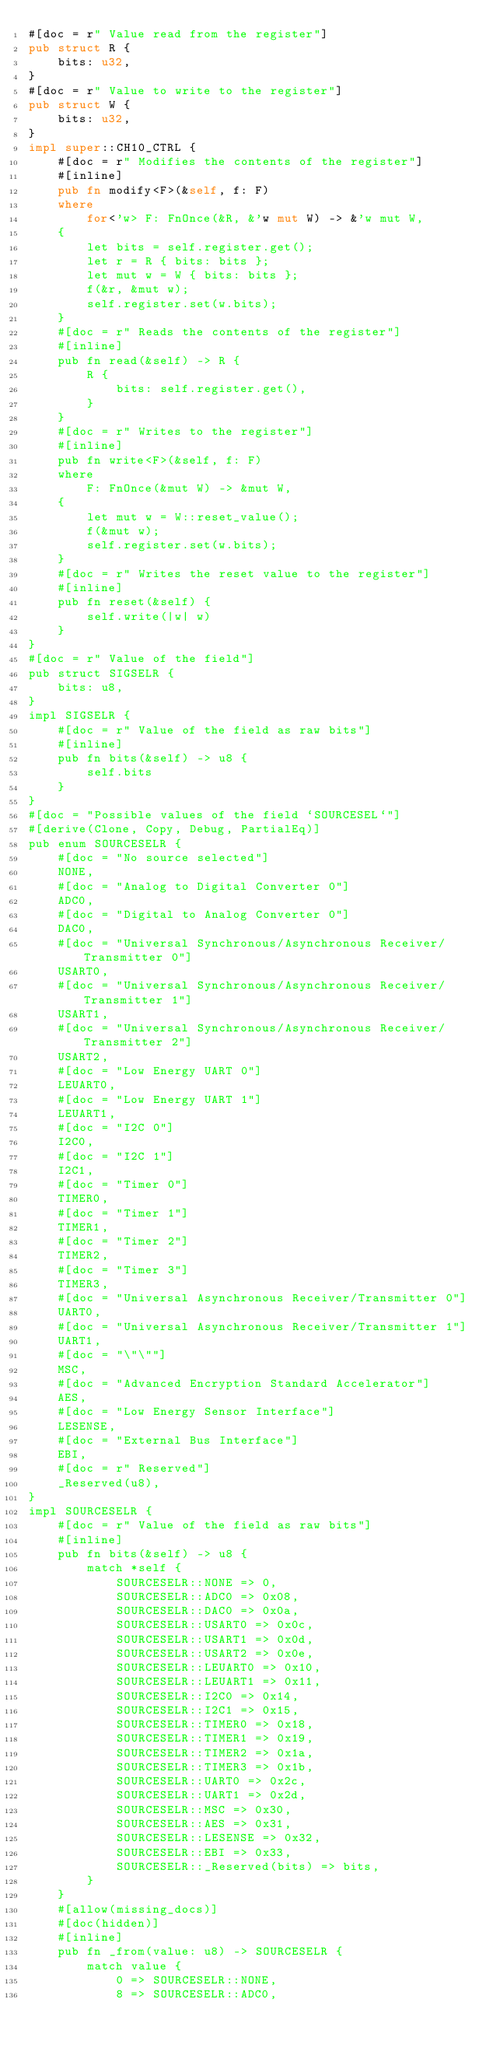Convert code to text. <code><loc_0><loc_0><loc_500><loc_500><_Rust_>#[doc = r" Value read from the register"]
pub struct R {
    bits: u32,
}
#[doc = r" Value to write to the register"]
pub struct W {
    bits: u32,
}
impl super::CH10_CTRL {
    #[doc = r" Modifies the contents of the register"]
    #[inline]
    pub fn modify<F>(&self, f: F)
    where
        for<'w> F: FnOnce(&R, &'w mut W) -> &'w mut W,
    {
        let bits = self.register.get();
        let r = R { bits: bits };
        let mut w = W { bits: bits };
        f(&r, &mut w);
        self.register.set(w.bits);
    }
    #[doc = r" Reads the contents of the register"]
    #[inline]
    pub fn read(&self) -> R {
        R {
            bits: self.register.get(),
        }
    }
    #[doc = r" Writes to the register"]
    #[inline]
    pub fn write<F>(&self, f: F)
    where
        F: FnOnce(&mut W) -> &mut W,
    {
        let mut w = W::reset_value();
        f(&mut w);
        self.register.set(w.bits);
    }
    #[doc = r" Writes the reset value to the register"]
    #[inline]
    pub fn reset(&self) {
        self.write(|w| w)
    }
}
#[doc = r" Value of the field"]
pub struct SIGSELR {
    bits: u8,
}
impl SIGSELR {
    #[doc = r" Value of the field as raw bits"]
    #[inline]
    pub fn bits(&self) -> u8 {
        self.bits
    }
}
#[doc = "Possible values of the field `SOURCESEL`"]
#[derive(Clone, Copy, Debug, PartialEq)]
pub enum SOURCESELR {
    #[doc = "No source selected"]
    NONE,
    #[doc = "Analog to Digital Converter 0"]
    ADC0,
    #[doc = "Digital to Analog Converter 0"]
    DAC0,
    #[doc = "Universal Synchronous/Asynchronous Receiver/Transmitter 0"]
    USART0,
    #[doc = "Universal Synchronous/Asynchronous Receiver/Transmitter 1"]
    USART1,
    #[doc = "Universal Synchronous/Asynchronous Receiver/Transmitter 2"]
    USART2,
    #[doc = "Low Energy UART 0"]
    LEUART0,
    #[doc = "Low Energy UART 1"]
    LEUART1,
    #[doc = "I2C 0"]
    I2C0,
    #[doc = "I2C 1"]
    I2C1,
    #[doc = "Timer 0"]
    TIMER0,
    #[doc = "Timer 1"]
    TIMER1,
    #[doc = "Timer 2"]
    TIMER2,
    #[doc = "Timer 3"]
    TIMER3,
    #[doc = "Universal Asynchronous Receiver/Transmitter 0"]
    UART0,
    #[doc = "Universal Asynchronous Receiver/Transmitter 1"]
    UART1,
    #[doc = "\"\""]
    MSC,
    #[doc = "Advanced Encryption Standard Accelerator"]
    AES,
    #[doc = "Low Energy Sensor Interface"]
    LESENSE,
    #[doc = "External Bus Interface"]
    EBI,
    #[doc = r" Reserved"]
    _Reserved(u8),
}
impl SOURCESELR {
    #[doc = r" Value of the field as raw bits"]
    #[inline]
    pub fn bits(&self) -> u8 {
        match *self {
            SOURCESELR::NONE => 0,
            SOURCESELR::ADC0 => 0x08,
            SOURCESELR::DAC0 => 0x0a,
            SOURCESELR::USART0 => 0x0c,
            SOURCESELR::USART1 => 0x0d,
            SOURCESELR::USART2 => 0x0e,
            SOURCESELR::LEUART0 => 0x10,
            SOURCESELR::LEUART1 => 0x11,
            SOURCESELR::I2C0 => 0x14,
            SOURCESELR::I2C1 => 0x15,
            SOURCESELR::TIMER0 => 0x18,
            SOURCESELR::TIMER1 => 0x19,
            SOURCESELR::TIMER2 => 0x1a,
            SOURCESELR::TIMER3 => 0x1b,
            SOURCESELR::UART0 => 0x2c,
            SOURCESELR::UART1 => 0x2d,
            SOURCESELR::MSC => 0x30,
            SOURCESELR::AES => 0x31,
            SOURCESELR::LESENSE => 0x32,
            SOURCESELR::EBI => 0x33,
            SOURCESELR::_Reserved(bits) => bits,
        }
    }
    #[allow(missing_docs)]
    #[doc(hidden)]
    #[inline]
    pub fn _from(value: u8) -> SOURCESELR {
        match value {
            0 => SOURCESELR::NONE,
            8 => SOURCESELR::ADC0,</code> 